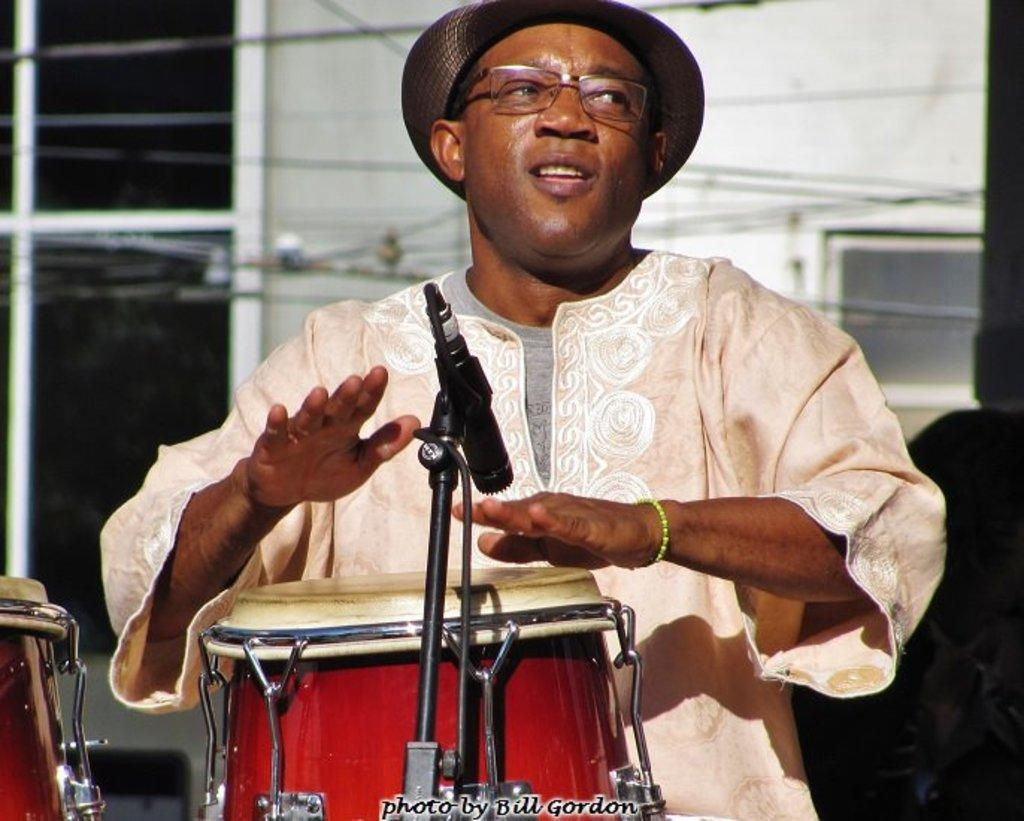What is the man in the image doing? The man is playing drums. What is the man using while playing drums? The man is using a microphone while playing drums. What type of boundary can be seen in the image? There is no boundary present in the image. What is the man wearing on his back in the image? The man is not wearing anything on his back in the image. What type of crown is the man wearing in the image? The man is not wearing any crown in the image. 